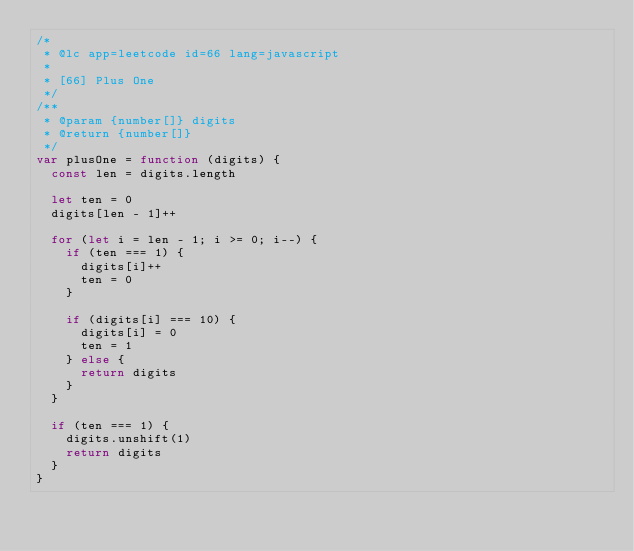Convert code to text. <code><loc_0><loc_0><loc_500><loc_500><_JavaScript_>/*
 * @lc app=leetcode id=66 lang=javascript
 *
 * [66] Plus One
 */
/**
 * @param {number[]} digits
 * @return {number[]}
 */
var plusOne = function (digits) {
  const len = digits.length

  let ten = 0
  digits[len - 1]++

  for (let i = len - 1; i >= 0; i--) {
    if (ten === 1) {
      digits[i]++
      ten = 0
    }

    if (digits[i] === 10) {
      digits[i] = 0
      ten = 1
    } else {
      return digits
    }
  }

  if (ten === 1) {
    digits.unshift(1)
    return digits
  }
}
</code> 